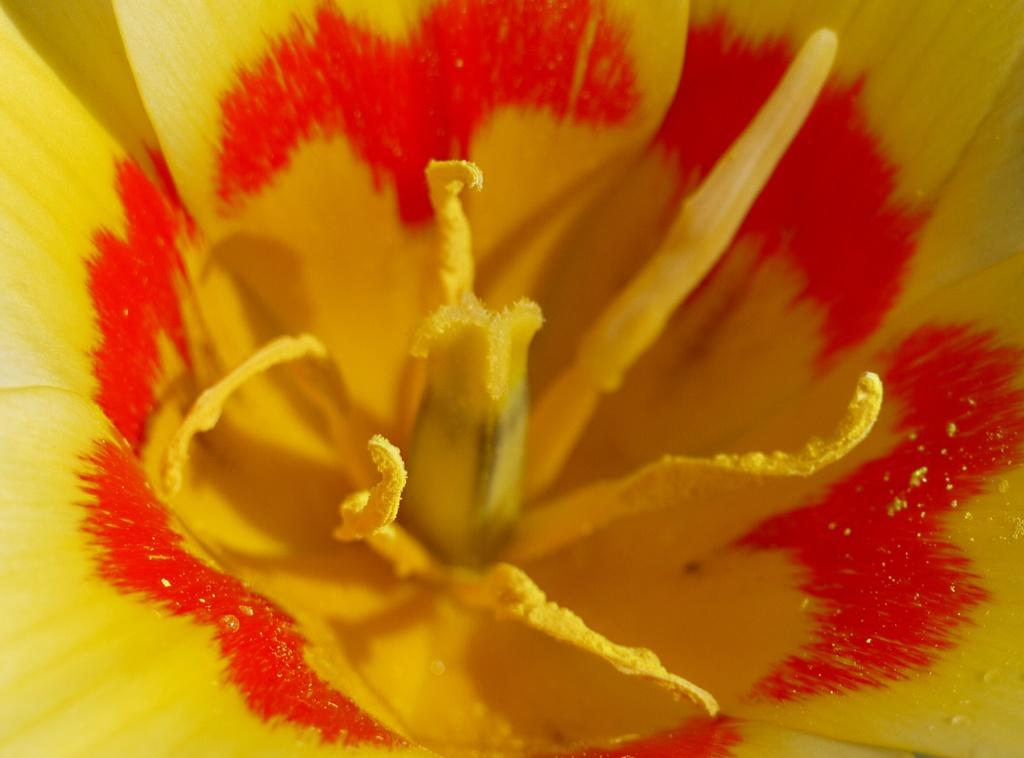What type of flower is in the image? There is a yellow flower in the image. Can you describe the appearance of the flower? Droplets are present on the petals of the flower. How many houses can be seen in the image? There are no houses present in the image; it features a yellow flower with droplets on its petals. What type of riddle is associated with the flower in the image? There is no riddle associated with the flower in the image; it simply shows a yellow flower with droplets on its petals. 